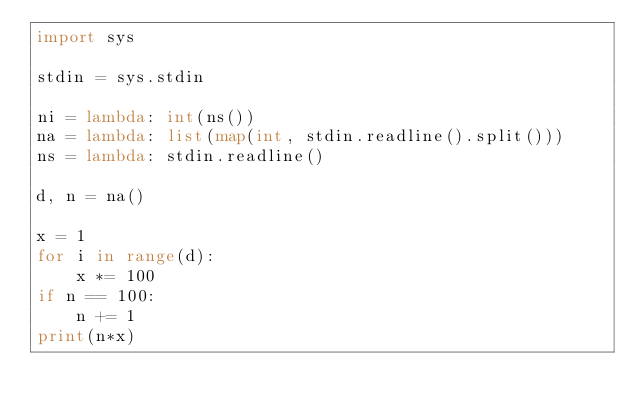Convert code to text. <code><loc_0><loc_0><loc_500><loc_500><_Python_>import sys

stdin = sys.stdin

ni = lambda: int(ns())
na = lambda: list(map(int, stdin.readline().split()))
ns = lambda: stdin.readline()

d, n = na()

x = 1
for i in range(d):
    x *= 100
if n == 100:
    n += 1
print(n*x)
</code> 